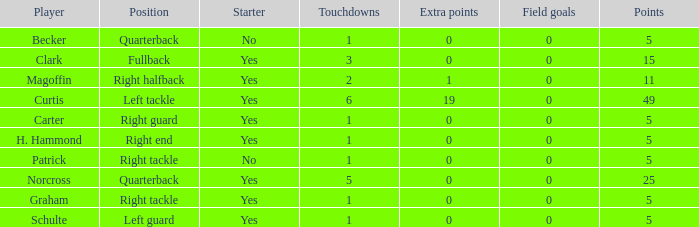Name the extra points for left guard 0.0. 